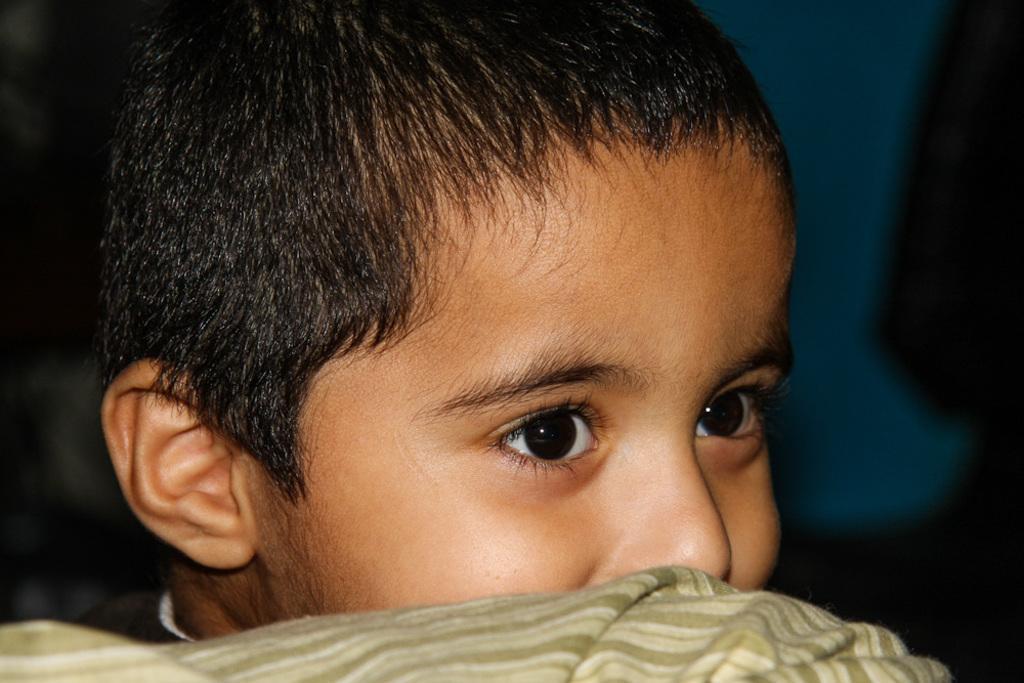Describe this image in one or two sentences. Here we can see kid face. Background it is blur and blue color. 